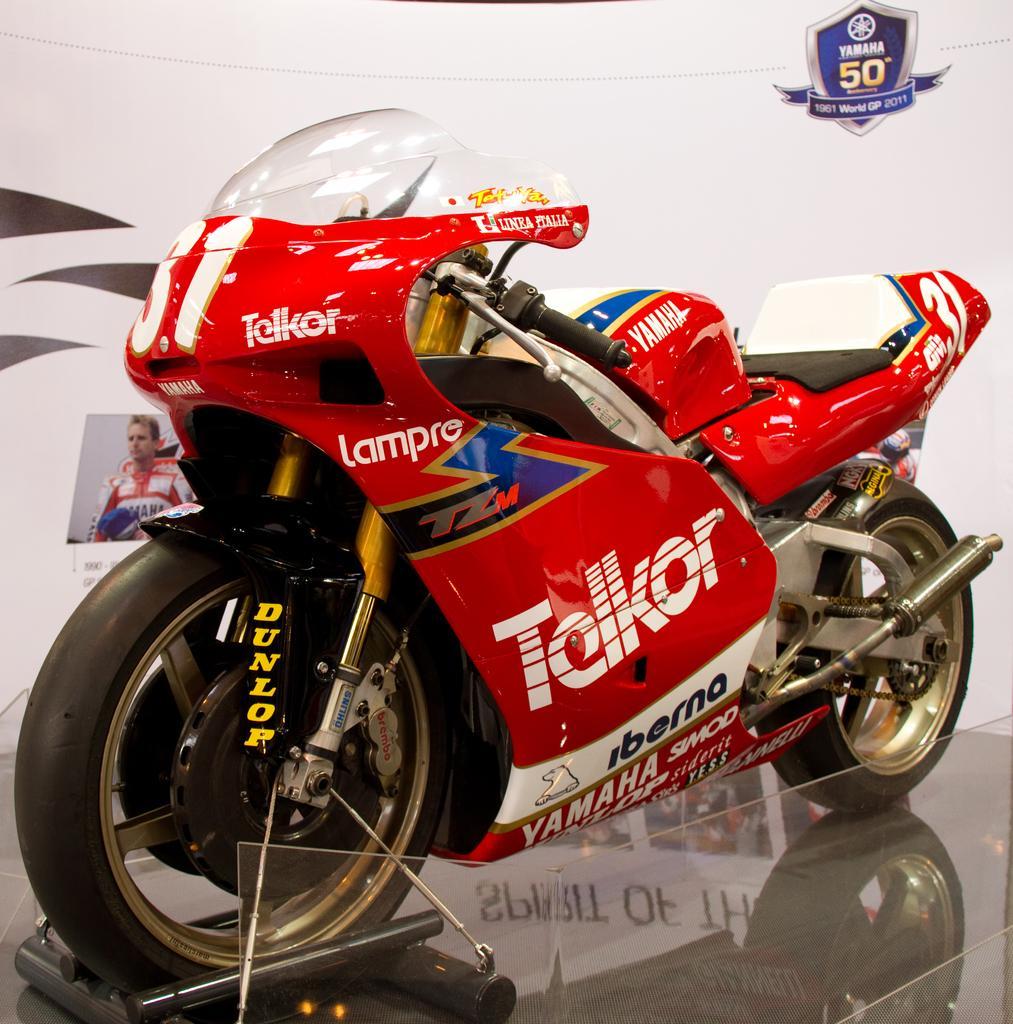Can you describe this image briefly? In this picture there is a sports bike in the center of the image and there is a flex in the background area of the image. 